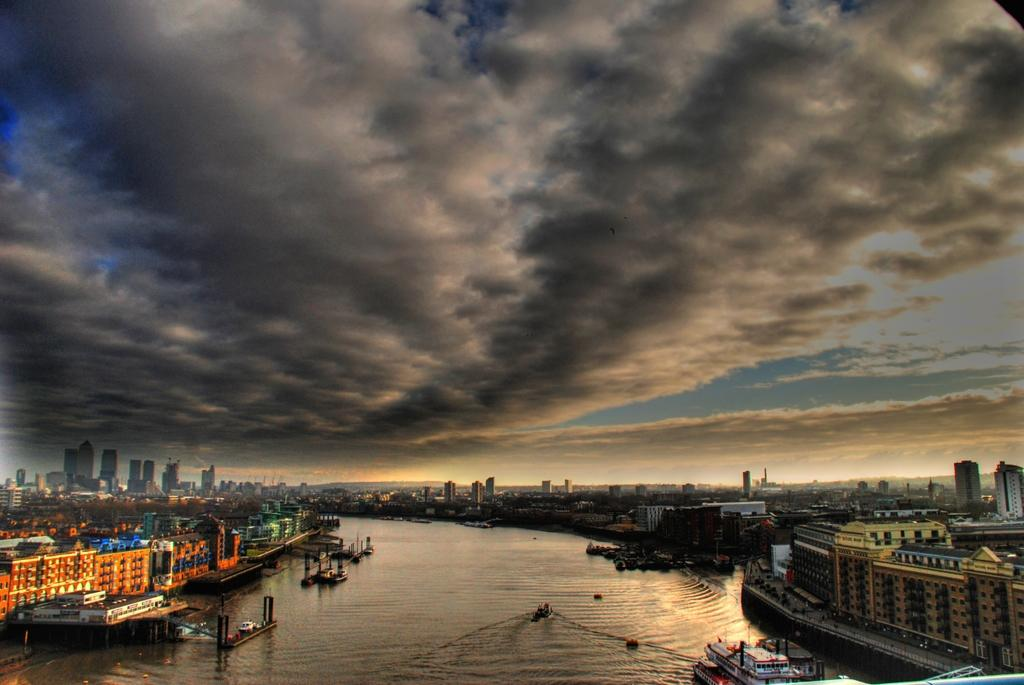What is the main element in the image? There is water in the image. What can be seen floating on the water? There are boats in the water. What structures are visible in the image? There are buildings visible in the image. What is present in the sky in the image? There are clouds in the image. What else can be seen in the sky in the image? The sky is visible in the image. How many legs can be seen on the bee in the image? There is no bee present in the image, so the number of legs cannot be determined. 